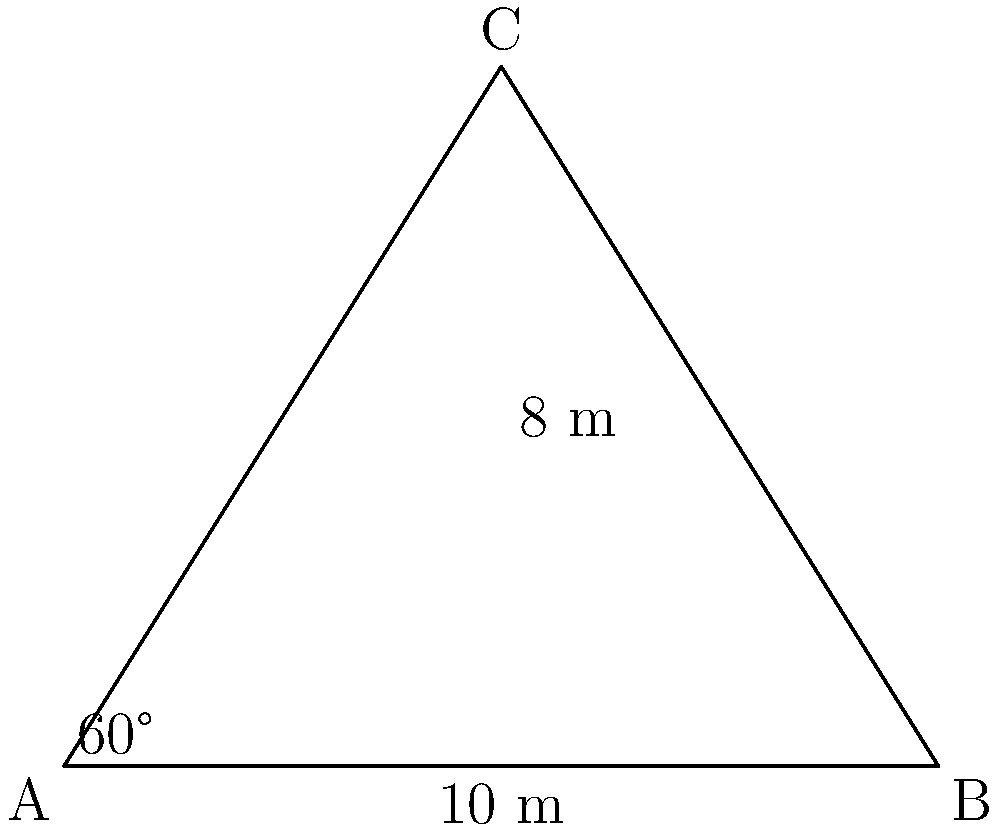A triangular cross-section of a dam has a base of 10 meters and a height of 8 meters. The angle between the base and one side is 60°. Calculate the area of this triangular cross-section. To solve this problem, we'll use trigonometric formulas and the given information:

1) We have a triangle ABC with:
   - Base (AB) = 10 m
   - Height (CD) = 8 m
   - Angle BAC = 60°

2) The area of a triangle can be calculated using the formula:
   $$Area = \frac{1}{2} \times base \times height$$

3) Substituting the known values:
   $$Area = \frac{1}{2} \times 10 \times 8 = 40 \text{ m}^2$$

4) We can verify this result using another formula:
   $$Area = \frac{1}{2} \times a^2 \times \sin(C)$$
   Where $a$ is the side adjacent to the 60° angle, and $C$ is the angle at the top of the triangle.

5) To find $a$, we can use the tangent function:
   $$\tan(60°) = \frac{8}{a/2}$$
   $$a = \frac{16}{\sqrt{3}} \approx 9.24 \text{ m}$$

6) The angle $C$ can be found by subtracting the other two angles from 180°:
   $$C = 180° - 90° - 60° = 30°$$

7) Now we can use the second formula:
   $$Area = \frac{1}{2} \times (\frac{16}{\sqrt{3}})^2 \times \sin(30°)$$
   $$= \frac{1}{2} \times \frac{256}{3} \times \frac{1}{2} = \frac{256}{12} = 40 \text{ m}^2$$

This confirms our initial calculation.
Answer: 40 m² 